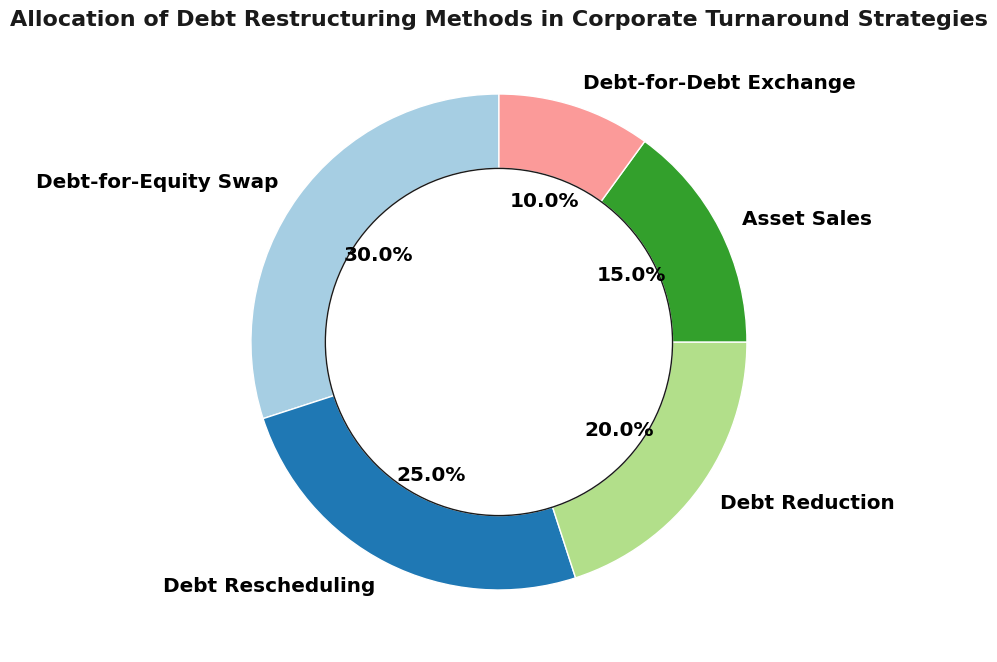Which method has the largest percentage of allocation in debt restructuring strategies? The pie chart shows the percentages of various debt restructuring methods used, and the segment for Debt-for-Equity Swap has the largest value.
Answer: Debt-for-Equity Swap How much more is the percentage of Debt-for-Equity Swap compared to Debt Reduction? Debt-for-Equity Swap is 30%, and Debt Reduction is 20%. The difference between them is 30% - 20%.
Answer: 10% What is the combined percentage of Debt Rescheduling and Asset Sales? To find the combined percentage, add the values for Debt Rescheduling and Asset Sales: 25% + 15%.
Answer: 40% Which method has the smallest allocation in the pie chart? By observing the pie chart, the segment with the smallest percentage is Debt-for-Debt Exchange.
Answer: Debt-for-Debt Exchange What is the average percentage allocation of all the methods shown? Sum all percentages: 30% + 25% + 20% + 15% + 10% = 100%. Divide this sum by the number of methods, which is 5.
Answer: 20% Are there any methods that have an equal allocation percentage in the chart? By checking the pie chart, no two segments have equal percentages.
Answer: No If Debt-for-Equity Swap and Debt Reduction percentages were combined, what would their total be? Adding the percentages of Debt-for-Equity Swap (30%) and Debt Reduction (20%) gives: 30% + 20%.
Answer: 50% Which visual attribute helps identify the categories in the pie chart? The pie chart uses colors to differentiate between the various categories of debt restructuring methods.
Answer: Colors 